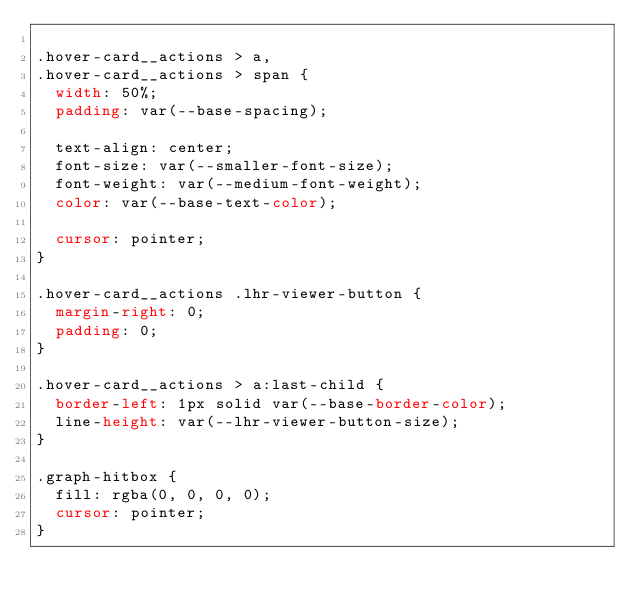<code> <loc_0><loc_0><loc_500><loc_500><_CSS_>
.hover-card__actions > a,
.hover-card__actions > span {
  width: 50%;
  padding: var(--base-spacing);

  text-align: center;
  font-size: var(--smaller-font-size);
  font-weight: var(--medium-font-weight);
  color: var(--base-text-color);

  cursor: pointer;
}

.hover-card__actions .lhr-viewer-button {
  margin-right: 0;
  padding: 0;
}

.hover-card__actions > a:last-child {
  border-left: 1px solid var(--base-border-color);
  line-height: var(--lhr-viewer-button-size);
}

.graph-hitbox {
  fill: rgba(0, 0, 0, 0);
  cursor: pointer;
}
</code> 